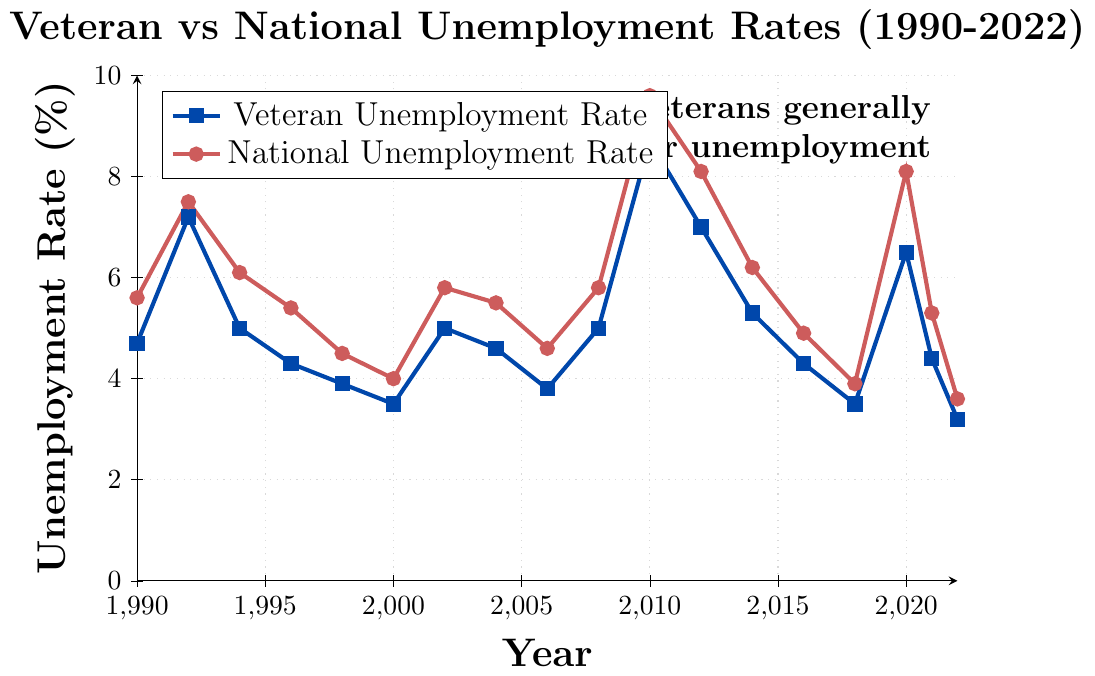What year had the highest veteran unemployment rate? In the figure, the highest point for the veteran unemployment rate line occurs in 2010.
Answer: 2010 Compare the veteran and national unemployment rates in 2002. Which is higher? At the intersection of 2002 on the x-axis, the veteran unemployment rate is 5.0% while the national unemployment rate is 5.8%. The national rate is higher.
Answer: National unemployment rate In which year did the veteran unemployment rate first drop below 4.0%? The veteran unemployment rate first falls below 4.0% in 1998 as the value is 3.9%.
Answer: 1998 By how much did the veteran unemployment rate change from 2010 to 2012? In 2010, the veteran unemployment rate was 8.7%, and in 2012 it was 7.0%. The change is 8.7% - 7.0% = 1.7%.
Answer: 1.7% What is the average national unemployment rate from 1990 to 2000? Summing the national unemployment rates for the years from 1990 to 2000 and dividing by the number of points: (5.6 + 7.5 + 6.1 + 5.4 + 4.5 + 4.0) / 6.
Answer: 5.52 Is there any year where the veteran unemployment rate is higher than the national unemployment rate after 1990? By reviewing the plot, the veteran unemployment rate is higher than the national rate in 2010.
Answer: 2010 What visual differences distinguish the lines representing veteran and national unemployment rates? The veteran unemployment rate line is depicted in blue squares, while the national unemployment rate is shown in red circles.
Answer: Color and markers 